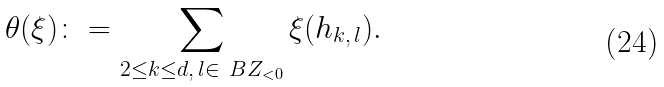<formula> <loc_0><loc_0><loc_500><loc_500>\theta ( \xi ) \colon = \sum _ { 2 \leq k \leq d , \, l \in \ B Z _ { < 0 } } \xi ( h _ { k , \, l } ) .</formula> 